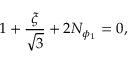<formula> <loc_0><loc_0><loc_500><loc_500>1 + \frac { \xi } { \sqrt { 3 } } + 2 N _ { \phi _ { 1 } } = 0 ,</formula> 